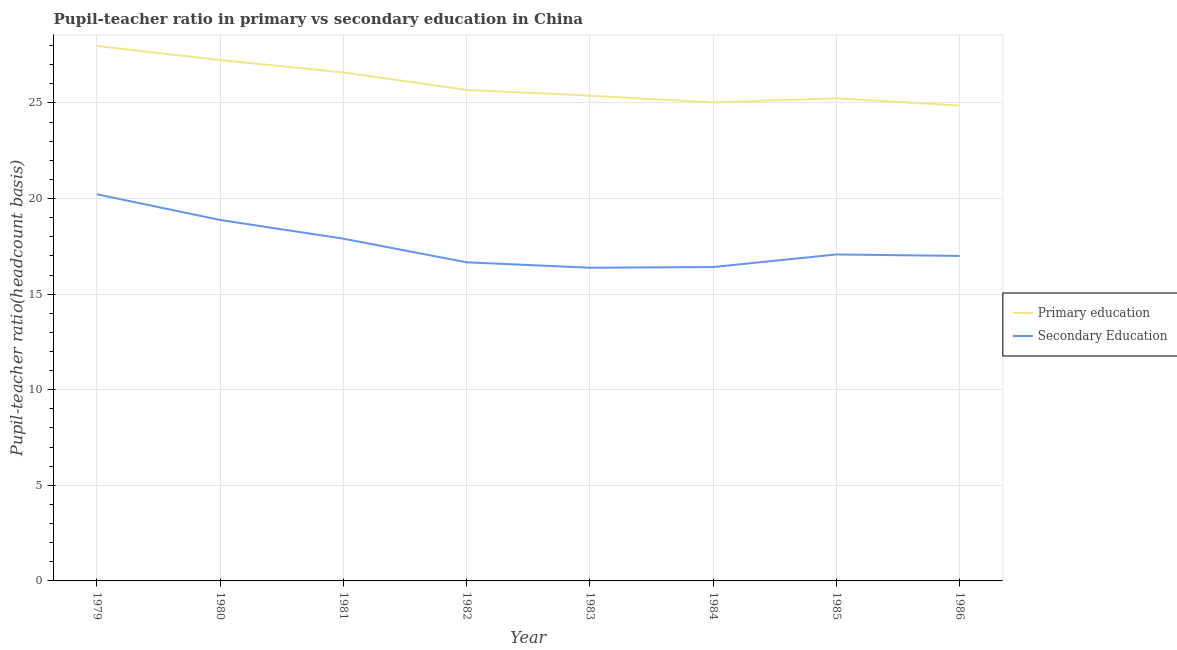Does the line corresponding to pupil teacher ratio on secondary education intersect with the line corresponding to pupil-teacher ratio in primary education?
Make the answer very short. No. What is the pupil-teacher ratio in primary education in 1985?
Provide a succinct answer. 25.25. Across all years, what is the maximum pupil-teacher ratio in primary education?
Provide a succinct answer. 27.98. Across all years, what is the minimum pupil-teacher ratio in primary education?
Make the answer very short. 24.87. In which year was the pupil-teacher ratio in primary education maximum?
Offer a very short reply. 1979. What is the total pupil teacher ratio on secondary education in the graph?
Your answer should be compact. 140.56. What is the difference between the pupil-teacher ratio in primary education in 1984 and that in 1985?
Your answer should be compact. -0.22. What is the difference between the pupil teacher ratio on secondary education in 1986 and the pupil-teacher ratio in primary education in 1984?
Offer a very short reply. -8.03. What is the average pupil teacher ratio on secondary education per year?
Offer a terse response. 17.57. In the year 1982, what is the difference between the pupil teacher ratio on secondary education and pupil-teacher ratio in primary education?
Offer a terse response. -9.02. What is the ratio of the pupil-teacher ratio in primary education in 1981 to that in 1986?
Ensure brevity in your answer.  1.07. Is the pupil-teacher ratio in primary education in 1983 less than that in 1985?
Make the answer very short. No. Is the difference between the pupil teacher ratio on secondary education in 1983 and 1986 greater than the difference between the pupil-teacher ratio in primary education in 1983 and 1986?
Offer a very short reply. No. What is the difference between the highest and the second highest pupil-teacher ratio in primary education?
Make the answer very short. 0.74. What is the difference between the highest and the lowest pupil-teacher ratio in primary education?
Provide a short and direct response. 3.12. Is the pupil-teacher ratio in primary education strictly less than the pupil teacher ratio on secondary education over the years?
Offer a very short reply. No. How many lines are there?
Provide a short and direct response. 2. What is the difference between two consecutive major ticks on the Y-axis?
Offer a very short reply. 5. Does the graph contain grids?
Provide a short and direct response. Yes. Where does the legend appear in the graph?
Provide a succinct answer. Center right. How many legend labels are there?
Offer a terse response. 2. How are the legend labels stacked?
Make the answer very short. Vertical. What is the title of the graph?
Your answer should be compact. Pupil-teacher ratio in primary vs secondary education in China. What is the label or title of the X-axis?
Make the answer very short. Year. What is the label or title of the Y-axis?
Provide a succinct answer. Pupil-teacher ratio(headcount basis). What is the Pupil-teacher ratio(headcount basis) of Primary education in 1979?
Ensure brevity in your answer.  27.98. What is the Pupil-teacher ratio(headcount basis) in Secondary Education in 1979?
Your answer should be very brief. 20.23. What is the Pupil-teacher ratio(headcount basis) of Primary education in 1980?
Keep it short and to the point. 27.25. What is the Pupil-teacher ratio(headcount basis) of Secondary Education in 1980?
Keep it short and to the point. 18.88. What is the Pupil-teacher ratio(headcount basis) in Primary education in 1981?
Keep it short and to the point. 26.6. What is the Pupil-teacher ratio(headcount basis) of Secondary Education in 1981?
Offer a very short reply. 17.9. What is the Pupil-teacher ratio(headcount basis) in Primary education in 1982?
Give a very brief answer. 25.69. What is the Pupil-teacher ratio(headcount basis) of Secondary Education in 1982?
Your answer should be very brief. 16.67. What is the Pupil-teacher ratio(headcount basis) in Primary education in 1983?
Your answer should be very brief. 25.38. What is the Pupil-teacher ratio(headcount basis) of Secondary Education in 1983?
Offer a very short reply. 16.38. What is the Pupil-teacher ratio(headcount basis) of Primary education in 1984?
Your answer should be very brief. 25.03. What is the Pupil-teacher ratio(headcount basis) of Secondary Education in 1984?
Your answer should be compact. 16.42. What is the Pupil-teacher ratio(headcount basis) in Primary education in 1985?
Offer a very short reply. 25.25. What is the Pupil-teacher ratio(headcount basis) of Secondary Education in 1985?
Offer a terse response. 17.08. What is the Pupil-teacher ratio(headcount basis) of Primary education in 1986?
Your answer should be compact. 24.87. What is the Pupil-teacher ratio(headcount basis) in Secondary Education in 1986?
Provide a short and direct response. 17. Across all years, what is the maximum Pupil-teacher ratio(headcount basis) of Primary education?
Provide a short and direct response. 27.98. Across all years, what is the maximum Pupil-teacher ratio(headcount basis) of Secondary Education?
Your answer should be very brief. 20.23. Across all years, what is the minimum Pupil-teacher ratio(headcount basis) of Primary education?
Give a very brief answer. 24.87. Across all years, what is the minimum Pupil-teacher ratio(headcount basis) in Secondary Education?
Offer a terse response. 16.38. What is the total Pupil-teacher ratio(headcount basis) of Primary education in the graph?
Offer a very short reply. 208.04. What is the total Pupil-teacher ratio(headcount basis) in Secondary Education in the graph?
Ensure brevity in your answer.  140.56. What is the difference between the Pupil-teacher ratio(headcount basis) in Primary education in 1979 and that in 1980?
Provide a short and direct response. 0.74. What is the difference between the Pupil-teacher ratio(headcount basis) in Secondary Education in 1979 and that in 1980?
Offer a very short reply. 1.34. What is the difference between the Pupil-teacher ratio(headcount basis) of Primary education in 1979 and that in 1981?
Offer a very short reply. 1.39. What is the difference between the Pupil-teacher ratio(headcount basis) of Secondary Education in 1979 and that in 1981?
Keep it short and to the point. 2.32. What is the difference between the Pupil-teacher ratio(headcount basis) in Primary education in 1979 and that in 1982?
Ensure brevity in your answer.  2.3. What is the difference between the Pupil-teacher ratio(headcount basis) of Secondary Education in 1979 and that in 1982?
Your answer should be very brief. 3.56. What is the difference between the Pupil-teacher ratio(headcount basis) of Primary education in 1979 and that in 1983?
Your response must be concise. 2.6. What is the difference between the Pupil-teacher ratio(headcount basis) of Secondary Education in 1979 and that in 1983?
Your answer should be compact. 3.84. What is the difference between the Pupil-teacher ratio(headcount basis) in Primary education in 1979 and that in 1984?
Your answer should be very brief. 2.95. What is the difference between the Pupil-teacher ratio(headcount basis) of Secondary Education in 1979 and that in 1984?
Make the answer very short. 3.81. What is the difference between the Pupil-teacher ratio(headcount basis) of Primary education in 1979 and that in 1985?
Your response must be concise. 2.74. What is the difference between the Pupil-teacher ratio(headcount basis) of Secondary Education in 1979 and that in 1985?
Make the answer very short. 3.15. What is the difference between the Pupil-teacher ratio(headcount basis) in Primary education in 1979 and that in 1986?
Offer a very short reply. 3.12. What is the difference between the Pupil-teacher ratio(headcount basis) of Secondary Education in 1979 and that in 1986?
Offer a very short reply. 3.23. What is the difference between the Pupil-teacher ratio(headcount basis) of Primary education in 1980 and that in 1981?
Keep it short and to the point. 0.65. What is the difference between the Pupil-teacher ratio(headcount basis) of Secondary Education in 1980 and that in 1981?
Your answer should be compact. 0.98. What is the difference between the Pupil-teacher ratio(headcount basis) of Primary education in 1980 and that in 1982?
Offer a terse response. 1.56. What is the difference between the Pupil-teacher ratio(headcount basis) of Secondary Education in 1980 and that in 1982?
Offer a very short reply. 2.21. What is the difference between the Pupil-teacher ratio(headcount basis) in Primary education in 1980 and that in 1983?
Make the answer very short. 1.86. What is the difference between the Pupil-teacher ratio(headcount basis) in Secondary Education in 1980 and that in 1983?
Your answer should be very brief. 2.5. What is the difference between the Pupil-teacher ratio(headcount basis) in Primary education in 1980 and that in 1984?
Ensure brevity in your answer.  2.21. What is the difference between the Pupil-teacher ratio(headcount basis) in Secondary Education in 1980 and that in 1984?
Your answer should be very brief. 2.46. What is the difference between the Pupil-teacher ratio(headcount basis) in Primary education in 1980 and that in 1985?
Keep it short and to the point. 2. What is the difference between the Pupil-teacher ratio(headcount basis) of Secondary Education in 1980 and that in 1985?
Give a very brief answer. 1.8. What is the difference between the Pupil-teacher ratio(headcount basis) of Primary education in 1980 and that in 1986?
Offer a very short reply. 2.38. What is the difference between the Pupil-teacher ratio(headcount basis) of Secondary Education in 1980 and that in 1986?
Provide a short and direct response. 1.88. What is the difference between the Pupil-teacher ratio(headcount basis) of Primary education in 1981 and that in 1982?
Your answer should be compact. 0.91. What is the difference between the Pupil-teacher ratio(headcount basis) in Secondary Education in 1981 and that in 1982?
Give a very brief answer. 1.24. What is the difference between the Pupil-teacher ratio(headcount basis) in Primary education in 1981 and that in 1983?
Your answer should be compact. 1.22. What is the difference between the Pupil-teacher ratio(headcount basis) of Secondary Education in 1981 and that in 1983?
Provide a short and direct response. 1.52. What is the difference between the Pupil-teacher ratio(headcount basis) of Primary education in 1981 and that in 1984?
Provide a short and direct response. 1.57. What is the difference between the Pupil-teacher ratio(headcount basis) of Secondary Education in 1981 and that in 1984?
Your answer should be compact. 1.48. What is the difference between the Pupil-teacher ratio(headcount basis) in Primary education in 1981 and that in 1985?
Make the answer very short. 1.35. What is the difference between the Pupil-teacher ratio(headcount basis) of Secondary Education in 1981 and that in 1985?
Your answer should be compact. 0.82. What is the difference between the Pupil-teacher ratio(headcount basis) in Primary education in 1981 and that in 1986?
Make the answer very short. 1.73. What is the difference between the Pupil-teacher ratio(headcount basis) in Secondary Education in 1981 and that in 1986?
Your answer should be very brief. 0.9. What is the difference between the Pupil-teacher ratio(headcount basis) in Primary education in 1982 and that in 1983?
Offer a terse response. 0.3. What is the difference between the Pupil-teacher ratio(headcount basis) in Secondary Education in 1982 and that in 1983?
Your answer should be compact. 0.28. What is the difference between the Pupil-teacher ratio(headcount basis) of Primary education in 1982 and that in 1984?
Your response must be concise. 0.66. What is the difference between the Pupil-teacher ratio(headcount basis) of Secondary Education in 1982 and that in 1984?
Provide a succinct answer. 0.25. What is the difference between the Pupil-teacher ratio(headcount basis) of Primary education in 1982 and that in 1985?
Ensure brevity in your answer.  0.44. What is the difference between the Pupil-teacher ratio(headcount basis) of Secondary Education in 1982 and that in 1985?
Your answer should be very brief. -0.41. What is the difference between the Pupil-teacher ratio(headcount basis) of Primary education in 1982 and that in 1986?
Offer a terse response. 0.82. What is the difference between the Pupil-teacher ratio(headcount basis) of Secondary Education in 1982 and that in 1986?
Provide a short and direct response. -0.33. What is the difference between the Pupil-teacher ratio(headcount basis) in Primary education in 1983 and that in 1984?
Your response must be concise. 0.35. What is the difference between the Pupil-teacher ratio(headcount basis) in Secondary Education in 1983 and that in 1984?
Provide a succinct answer. -0.04. What is the difference between the Pupil-teacher ratio(headcount basis) in Primary education in 1983 and that in 1985?
Offer a terse response. 0.13. What is the difference between the Pupil-teacher ratio(headcount basis) in Secondary Education in 1983 and that in 1985?
Your response must be concise. -0.69. What is the difference between the Pupil-teacher ratio(headcount basis) in Primary education in 1983 and that in 1986?
Provide a short and direct response. 0.52. What is the difference between the Pupil-teacher ratio(headcount basis) of Secondary Education in 1983 and that in 1986?
Provide a succinct answer. -0.62. What is the difference between the Pupil-teacher ratio(headcount basis) of Primary education in 1984 and that in 1985?
Provide a succinct answer. -0.22. What is the difference between the Pupil-teacher ratio(headcount basis) of Secondary Education in 1984 and that in 1985?
Ensure brevity in your answer.  -0.66. What is the difference between the Pupil-teacher ratio(headcount basis) of Primary education in 1984 and that in 1986?
Keep it short and to the point. 0.16. What is the difference between the Pupil-teacher ratio(headcount basis) of Secondary Education in 1984 and that in 1986?
Offer a terse response. -0.58. What is the difference between the Pupil-teacher ratio(headcount basis) in Primary education in 1985 and that in 1986?
Offer a very short reply. 0.38. What is the difference between the Pupil-teacher ratio(headcount basis) in Secondary Education in 1985 and that in 1986?
Your response must be concise. 0.08. What is the difference between the Pupil-teacher ratio(headcount basis) of Primary education in 1979 and the Pupil-teacher ratio(headcount basis) of Secondary Education in 1980?
Your response must be concise. 9.1. What is the difference between the Pupil-teacher ratio(headcount basis) in Primary education in 1979 and the Pupil-teacher ratio(headcount basis) in Secondary Education in 1981?
Provide a short and direct response. 10.08. What is the difference between the Pupil-teacher ratio(headcount basis) in Primary education in 1979 and the Pupil-teacher ratio(headcount basis) in Secondary Education in 1982?
Keep it short and to the point. 11.32. What is the difference between the Pupil-teacher ratio(headcount basis) in Primary education in 1979 and the Pupil-teacher ratio(headcount basis) in Secondary Education in 1983?
Provide a succinct answer. 11.6. What is the difference between the Pupil-teacher ratio(headcount basis) of Primary education in 1979 and the Pupil-teacher ratio(headcount basis) of Secondary Education in 1984?
Provide a short and direct response. 11.56. What is the difference between the Pupil-teacher ratio(headcount basis) of Primary education in 1979 and the Pupil-teacher ratio(headcount basis) of Secondary Education in 1985?
Ensure brevity in your answer.  10.9. What is the difference between the Pupil-teacher ratio(headcount basis) in Primary education in 1979 and the Pupil-teacher ratio(headcount basis) in Secondary Education in 1986?
Your response must be concise. 10.98. What is the difference between the Pupil-teacher ratio(headcount basis) of Primary education in 1980 and the Pupil-teacher ratio(headcount basis) of Secondary Education in 1981?
Make the answer very short. 9.34. What is the difference between the Pupil-teacher ratio(headcount basis) of Primary education in 1980 and the Pupil-teacher ratio(headcount basis) of Secondary Education in 1982?
Ensure brevity in your answer.  10.58. What is the difference between the Pupil-teacher ratio(headcount basis) in Primary education in 1980 and the Pupil-teacher ratio(headcount basis) in Secondary Education in 1983?
Offer a very short reply. 10.86. What is the difference between the Pupil-teacher ratio(headcount basis) of Primary education in 1980 and the Pupil-teacher ratio(headcount basis) of Secondary Education in 1984?
Ensure brevity in your answer.  10.83. What is the difference between the Pupil-teacher ratio(headcount basis) of Primary education in 1980 and the Pupil-teacher ratio(headcount basis) of Secondary Education in 1985?
Provide a succinct answer. 10.17. What is the difference between the Pupil-teacher ratio(headcount basis) of Primary education in 1980 and the Pupil-teacher ratio(headcount basis) of Secondary Education in 1986?
Your response must be concise. 10.25. What is the difference between the Pupil-teacher ratio(headcount basis) of Primary education in 1981 and the Pupil-teacher ratio(headcount basis) of Secondary Education in 1982?
Make the answer very short. 9.93. What is the difference between the Pupil-teacher ratio(headcount basis) of Primary education in 1981 and the Pupil-teacher ratio(headcount basis) of Secondary Education in 1983?
Your answer should be very brief. 10.21. What is the difference between the Pupil-teacher ratio(headcount basis) in Primary education in 1981 and the Pupil-teacher ratio(headcount basis) in Secondary Education in 1984?
Keep it short and to the point. 10.18. What is the difference between the Pupil-teacher ratio(headcount basis) of Primary education in 1981 and the Pupil-teacher ratio(headcount basis) of Secondary Education in 1985?
Offer a very short reply. 9.52. What is the difference between the Pupil-teacher ratio(headcount basis) of Primary education in 1981 and the Pupil-teacher ratio(headcount basis) of Secondary Education in 1986?
Offer a very short reply. 9.6. What is the difference between the Pupil-teacher ratio(headcount basis) in Primary education in 1982 and the Pupil-teacher ratio(headcount basis) in Secondary Education in 1983?
Keep it short and to the point. 9.3. What is the difference between the Pupil-teacher ratio(headcount basis) of Primary education in 1982 and the Pupil-teacher ratio(headcount basis) of Secondary Education in 1984?
Provide a succinct answer. 9.27. What is the difference between the Pupil-teacher ratio(headcount basis) of Primary education in 1982 and the Pupil-teacher ratio(headcount basis) of Secondary Education in 1985?
Make the answer very short. 8.61. What is the difference between the Pupil-teacher ratio(headcount basis) of Primary education in 1982 and the Pupil-teacher ratio(headcount basis) of Secondary Education in 1986?
Your response must be concise. 8.69. What is the difference between the Pupil-teacher ratio(headcount basis) of Primary education in 1983 and the Pupil-teacher ratio(headcount basis) of Secondary Education in 1984?
Give a very brief answer. 8.96. What is the difference between the Pupil-teacher ratio(headcount basis) in Primary education in 1983 and the Pupil-teacher ratio(headcount basis) in Secondary Education in 1985?
Provide a succinct answer. 8.3. What is the difference between the Pupil-teacher ratio(headcount basis) in Primary education in 1983 and the Pupil-teacher ratio(headcount basis) in Secondary Education in 1986?
Keep it short and to the point. 8.38. What is the difference between the Pupil-teacher ratio(headcount basis) in Primary education in 1984 and the Pupil-teacher ratio(headcount basis) in Secondary Education in 1985?
Offer a terse response. 7.95. What is the difference between the Pupil-teacher ratio(headcount basis) in Primary education in 1984 and the Pupil-teacher ratio(headcount basis) in Secondary Education in 1986?
Offer a terse response. 8.03. What is the difference between the Pupil-teacher ratio(headcount basis) of Primary education in 1985 and the Pupil-teacher ratio(headcount basis) of Secondary Education in 1986?
Offer a very short reply. 8.25. What is the average Pupil-teacher ratio(headcount basis) in Primary education per year?
Keep it short and to the point. 26. What is the average Pupil-teacher ratio(headcount basis) of Secondary Education per year?
Offer a terse response. 17.57. In the year 1979, what is the difference between the Pupil-teacher ratio(headcount basis) of Primary education and Pupil-teacher ratio(headcount basis) of Secondary Education?
Ensure brevity in your answer.  7.76. In the year 1980, what is the difference between the Pupil-teacher ratio(headcount basis) of Primary education and Pupil-teacher ratio(headcount basis) of Secondary Education?
Your answer should be compact. 8.36. In the year 1981, what is the difference between the Pupil-teacher ratio(headcount basis) in Primary education and Pupil-teacher ratio(headcount basis) in Secondary Education?
Make the answer very short. 8.7. In the year 1982, what is the difference between the Pupil-teacher ratio(headcount basis) in Primary education and Pupil-teacher ratio(headcount basis) in Secondary Education?
Provide a short and direct response. 9.02. In the year 1983, what is the difference between the Pupil-teacher ratio(headcount basis) in Primary education and Pupil-teacher ratio(headcount basis) in Secondary Education?
Offer a terse response. 9. In the year 1984, what is the difference between the Pupil-teacher ratio(headcount basis) of Primary education and Pupil-teacher ratio(headcount basis) of Secondary Education?
Your answer should be compact. 8.61. In the year 1985, what is the difference between the Pupil-teacher ratio(headcount basis) in Primary education and Pupil-teacher ratio(headcount basis) in Secondary Education?
Make the answer very short. 8.17. In the year 1986, what is the difference between the Pupil-teacher ratio(headcount basis) of Primary education and Pupil-teacher ratio(headcount basis) of Secondary Education?
Ensure brevity in your answer.  7.87. What is the ratio of the Pupil-teacher ratio(headcount basis) of Primary education in 1979 to that in 1980?
Provide a succinct answer. 1.03. What is the ratio of the Pupil-teacher ratio(headcount basis) in Secondary Education in 1979 to that in 1980?
Offer a very short reply. 1.07. What is the ratio of the Pupil-teacher ratio(headcount basis) in Primary education in 1979 to that in 1981?
Offer a very short reply. 1.05. What is the ratio of the Pupil-teacher ratio(headcount basis) in Secondary Education in 1979 to that in 1981?
Your answer should be very brief. 1.13. What is the ratio of the Pupil-teacher ratio(headcount basis) in Primary education in 1979 to that in 1982?
Keep it short and to the point. 1.09. What is the ratio of the Pupil-teacher ratio(headcount basis) of Secondary Education in 1979 to that in 1982?
Make the answer very short. 1.21. What is the ratio of the Pupil-teacher ratio(headcount basis) in Primary education in 1979 to that in 1983?
Make the answer very short. 1.1. What is the ratio of the Pupil-teacher ratio(headcount basis) of Secondary Education in 1979 to that in 1983?
Your response must be concise. 1.23. What is the ratio of the Pupil-teacher ratio(headcount basis) of Primary education in 1979 to that in 1984?
Provide a succinct answer. 1.12. What is the ratio of the Pupil-teacher ratio(headcount basis) in Secondary Education in 1979 to that in 1984?
Provide a succinct answer. 1.23. What is the ratio of the Pupil-teacher ratio(headcount basis) of Primary education in 1979 to that in 1985?
Offer a terse response. 1.11. What is the ratio of the Pupil-teacher ratio(headcount basis) in Secondary Education in 1979 to that in 1985?
Offer a terse response. 1.18. What is the ratio of the Pupil-teacher ratio(headcount basis) in Primary education in 1979 to that in 1986?
Offer a terse response. 1.13. What is the ratio of the Pupil-teacher ratio(headcount basis) of Secondary Education in 1979 to that in 1986?
Offer a terse response. 1.19. What is the ratio of the Pupil-teacher ratio(headcount basis) in Primary education in 1980 to that in 1981?
Your response must be concise. 1.02. What is the ratio of the Pupil-teacher ratio(headcount basis) of Secondary Education in 1980 to that in 1981?
Your answer should be very brief. 1.05. What is the ratio of the Pupil-teacher ratio(headcount basis) of Primary education in 1980 to that in 1982?
Keep it short and to the point. 1.06. What is the ratio of the Pupil-teacher ratio(headcount basis) in Secondary Education in 1980 to that in 1982?
Provide a succinct answer. 1.13. What is the ratio of the Pupil-teacher ratio(headcount basis) in Primary education in 1980 to that in 1983?
Offer a very short reply. 1.07. What is the ratio of the Pupil-teacher ratio(headcount basis) of Secondary Education in 1980 to that in 1983?
Keep it short and to the point. 1.15. What is the ratio of the Pupil-teacher ratio(headcount basis) of Primary education in 1980 to that in 1984?
Make the answer very short. 1.09. What is the ratio of the Pupil-teacher ratio(headcount basis) in Secondary Education in 1980 to that in 1984?
Offer a very short reply. 1.15. What is the ratio of the Pupil-teacher ratio(headcount basis) of Primary education in 1980 to that in 1985?
Your response must be concise. 1.08. What is the ratio of the Pupil-teacher ratio(headcount basis) in Secondary Education in 1980 to that in 1985?
Offer a very short reply. 1.11. What is the ratio of the Pupil-teacher ratio(headcount basis) of Primary education in 1980 to that in 1986?
Your answer should be very brief. 1.1. What is the ratio of the Pupil-teacher ratio(headcount basis) of Secondary Education in 1980 to that in 1986?
Make the answer very short. 1.11. What is the ratio of the Pupil-teacher ratio(headcount basis) of Primary education in 1981 to that in 1982?
Provide a succinct answer. 1.04. What is the ratio of the Pupil-teacher ratio(headcount basis) of Secondary Education in 1981 to that in 1982?
Ensure brevity in your answer.  1.07. What is the ratio of the Pupil-teacher ratio(headcount basis) in Primary education in 1981 to that in 1983?
Keep it short and to the point. 1.05. What is the ratio of the Pupil-teacher ratio(headcount basis) of Secondary Education in 1981 to that in 1983?
Provide a short and direct response. 1.09. What is the ratio of the Pupil-teacher ratio(headcount basis) in Primary education in 1981 to that in 1984?
Offer a very short reply. 1.06. What is the ratio of the Pupil-teacher ratio(headcount basis) in Secondary Education in 1981 to that in 1984?
Provide a short and direct response. 1.09. What is the ratio of the Pupil-teacher ratio(headcount basis) of Primary education in 1981 to that in 1985?
Ensure brevity in your answer.  1.05. What is the ratio of the Pupil-teacher ratio(headcount basis) in Secondary Education in 1981 to that in 1985?
Keep it short and to the point. 1.05. What is the ratio of the Pupil-teacher ratio(headcount basis) of Primary education in 1981 to that in 1986?
Offer a terse response. 1.07. What is the ratio of the Pupil-teacher ratio(headcount basis) in Secondary Education in 1981 to that in 1986?
Provide a short and direct response. 1.05. What is the ratio of the Pupil-teacher ratio(headcount basis) in Primary education in 1982 to that in 1983?
Keep it short and to the point. 1.01. What is the ratio of the Pupil-teacher ratio(headcount basis) of Secondary Education in 1982 to that in 1983?
Keep it short and to the point. 1.02. What is the ratio of the Pupil-teacher ratio(headcount basis) of Primary education in 1982 to that in 1984?
Make the answer very short. 1.03. What is the ratio of the Pupil-teacher ratio(headcount basis) of Secondary Education in 1982 to that in 1984?
Offer a very short reply. 1.02. What is the ratio of the Pupil-teacher ratio(headcount basis) of Primary education in 1982 to that in 1985?
Give a very brief answer. 1.02. What is the ratio of the Pupil-teacher ratio(headcount basis) in Secondary Education in 1982 to that in 1985?
Keep it short and to the point. 0.98. What is the ratio of the Pupil-teacher ratio(headcount basis) of Primary education in 1982 to that in 1986?
Offer a very short reply. 1.03. What is the ratio of the Pupil-teacher ratio(headcount basis) in Secondary Education in 1982 to that in 1986?
Give a very brief answer. 0.98. What is the ratio of the Pupil-teacher ratio(headcount basis) of Primary education in 1983 to that in 1984?
Make the answer very short. 1.01. What is the ratio of the Pupil-teacher ratio(headcount basis) of Secondary Education in 1983 to that in 1985?
Offer a very short reply. 0.96. What is the ratio of the Pupil-teacher ratio(headcount basis) in Primary education in 1983 to that in 1986?
Give a very brief answer. 1.02. What is the ratio of the Pupil-teacher ratio(headcount basis) in Secondary Education in 1983 to that in 1986?
Make the answer very short. 0.96. What is the ratio of the Pupil-teacher ratio(headcount basis) of Primary education in 1984 to that in 1985?
Offer a terse response. 0.99. What is the ratio of the Pupil-teacher ratio(headcount basis) in Secondary Education in 1984 to that in 1985?
Your response must be concise. 0.96. What is the ratio of the Pupil-teacher ratio(headcount basis) of Primary education in 1984 to that in 1986?
Ensure brevity in your answer.  1.01. What is the ratio of the Pupil-teacher ratio(headcount basis) of Secondary Education in 1984 to that in 1986?
Offer a terse response. 0.97. What is the ratio of the Pupil-teacher ratio(headcount basis) in Primary education in 1985 to that in 1986?
Give a very brief answer. 1.02. What is the difference between the highest and the second highest Pupil-teacher ratio(headcount basis) of Primary education?
Offer a very short reply. 0.74. What is the difference between the highest and the second highest Pupil-teacher ratio(headcount basis) in Secondary Education?
Provide a succinct answer. 1.34. What is the difference between the highest and the lowest Pupil-teacher ratio(headcount basis) in Primary education?
Provide a succinct answer. 3.12. What is the difference between the highest and the lowest Pupil-teacher ratio(headcount basis) in Secondary Education?
Your answer should be compact. 3.84. 